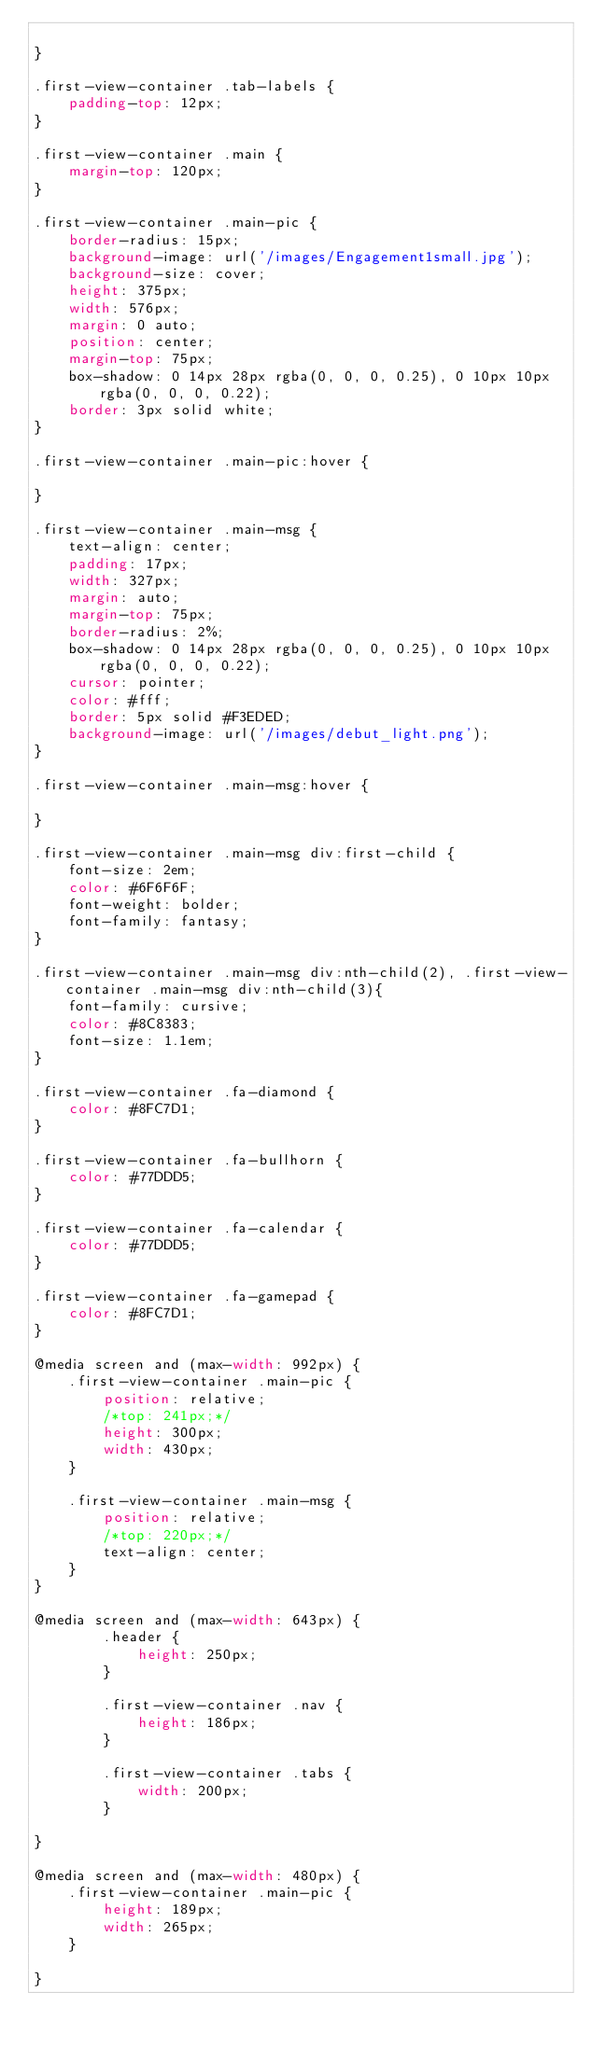Convert code to text. <code><loc_0><loc_0><loc_500><loc_500><_CSS_>	
}

.first-view-container .tab-labels {
    padding-top: 12px;
}

.first-view-container .main {
	margin-top: 120px;
}

.first-view-container .main-pic {
    border-radius: 15px;
    background-image: url('/images/Engagement1small.jpg');
    background-size: cover;
    height: 375px;
    width: 576px;
    margin: 0 auto;
    position: center;
    margin-top: 75px;
    box-shadow: 0 14px 28px rgba(0, 0, 0, 0.25), 0 10px 10px rgba(0, 0, 0, 0.22);
    border: 3px solid white;
}

.first-view-container .main-pic:hover {
    
}

.first-view-container .main-msg {
    text-align: center;
    padding: 17px;
    width: 327px;
    margin: auto;
    margin-top: 75px;
    border-radius: 2%;
    box-shadow: 0 14px 28px rgba(0, 0, 0, 0.25), 0 10px 10px rgba(0, 0, 0, 0.22);
    cursor: pointer;
    color: #fff;
    border: 5px solid #F3EDED;
    background-image: url('/images/debut_light.png');
}

.first-view-container .main-msg:hover {
    
}

.first-view-container .main-msg div:first-child {
    font-size: 2em;
    color: #6F6F6F;
    font-weight: bolder;
    font-family: fantasy;
}

.first-view-container .main-msg div:nth-child(2), .first-view-container .main-msg div:nth-child(3){
    font-family: cursive;
    color: #8C8383;
    font-size: 1.1em;
}

.first-view-container .fa-diamond {
    color: #8FC7D1;
}

.first-view-container .fa-bullhorn {
    color: #77DDD5;
}

.first-view-container .fa-calendar {
    color: #77DDD5;
}

.first-view-container .fa-gamepad {
    color: #8FC7D1;
}

@media screen and (max-width: 992px) {
	.first-view-container .main-pic {
		position: relative;
		/*top: 241px;*/
		height: 300px;
		width: 430px;
	}

	.first-view-container .main-msg {
		position: relative;
		/*top: 220px;*/
		text-align: center;
	}
}

@media screen and (max-width: 643px) {
		.header {
			height: 250px;
		}

		.first-view-container .nav {
			height: 186px;
		}

		.first-view-container .tabs {
			width: 200px;
		}

}

@media screen and (max-width: 480px) {
	.first-view-container .main-pic {
		height: 189px;
		width: 265px;
	}

}
</code> 